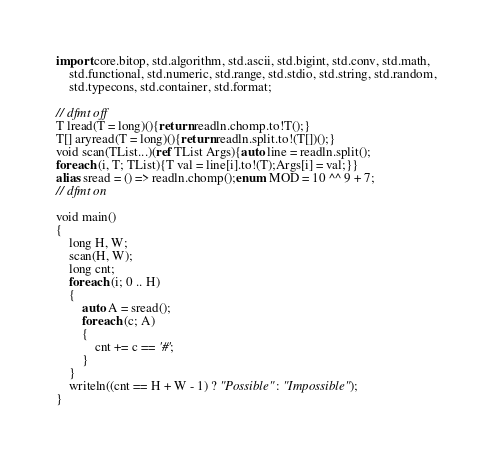<code> <loc_0><loc_0><loc_500><loc_500><_D_>import core.bitop, std.algorithm, std.ascii, std.bigint, std.conv, std.math,
    std.functional, std.numeric, std.range, std.stdio, std.string, std.random,
    std.typecons, std.container, std.format;

// dfmt off
T lread(T = long)(){return readln.chomp.to!T();}
T[] aryread(T = long)(){return readln.split.to!(T[])();}
void scan(TList...)(ref TList Args){auto line = readln.split();
foreach (i, T; TList){T val = line[i].to!(T);Args[i] = val;}}
alias sread = () => readln.chomp();enum MOD = 10 ^^ 9 + 7;
// dfmt on

void main()
{
    long H, W;
    scan(H, W);
    long cnt;
    foreach (i; 0 .. H)
    {
        auto A = sread();
        foreach (c; A)
        {
            cnt += c == '#';
        }
    }
    writeln((cnt == H + W - 1) ? "Possible" : "Impossible");
}
</code> 